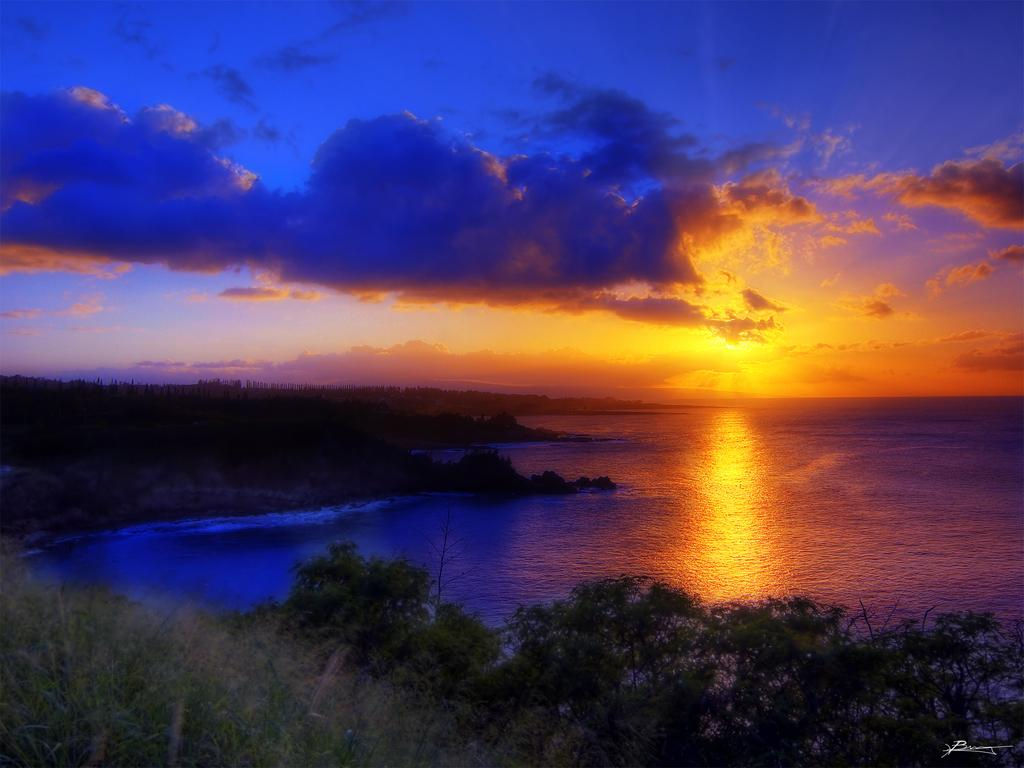What type of plants can be seen in the image? There are plants with flowers in the image. What other natural elements are present in the image? There is a group of trees and a large water body in the image. What is the weather like in the image? The sky appears cloudy in the image. Can the sun be seen in the image? Yes, the sun is visible in the image. What team is responsible for maintaining the plants in the image? There is no team present in the image, as it is a natural scene with plants, trees, and a water body. 